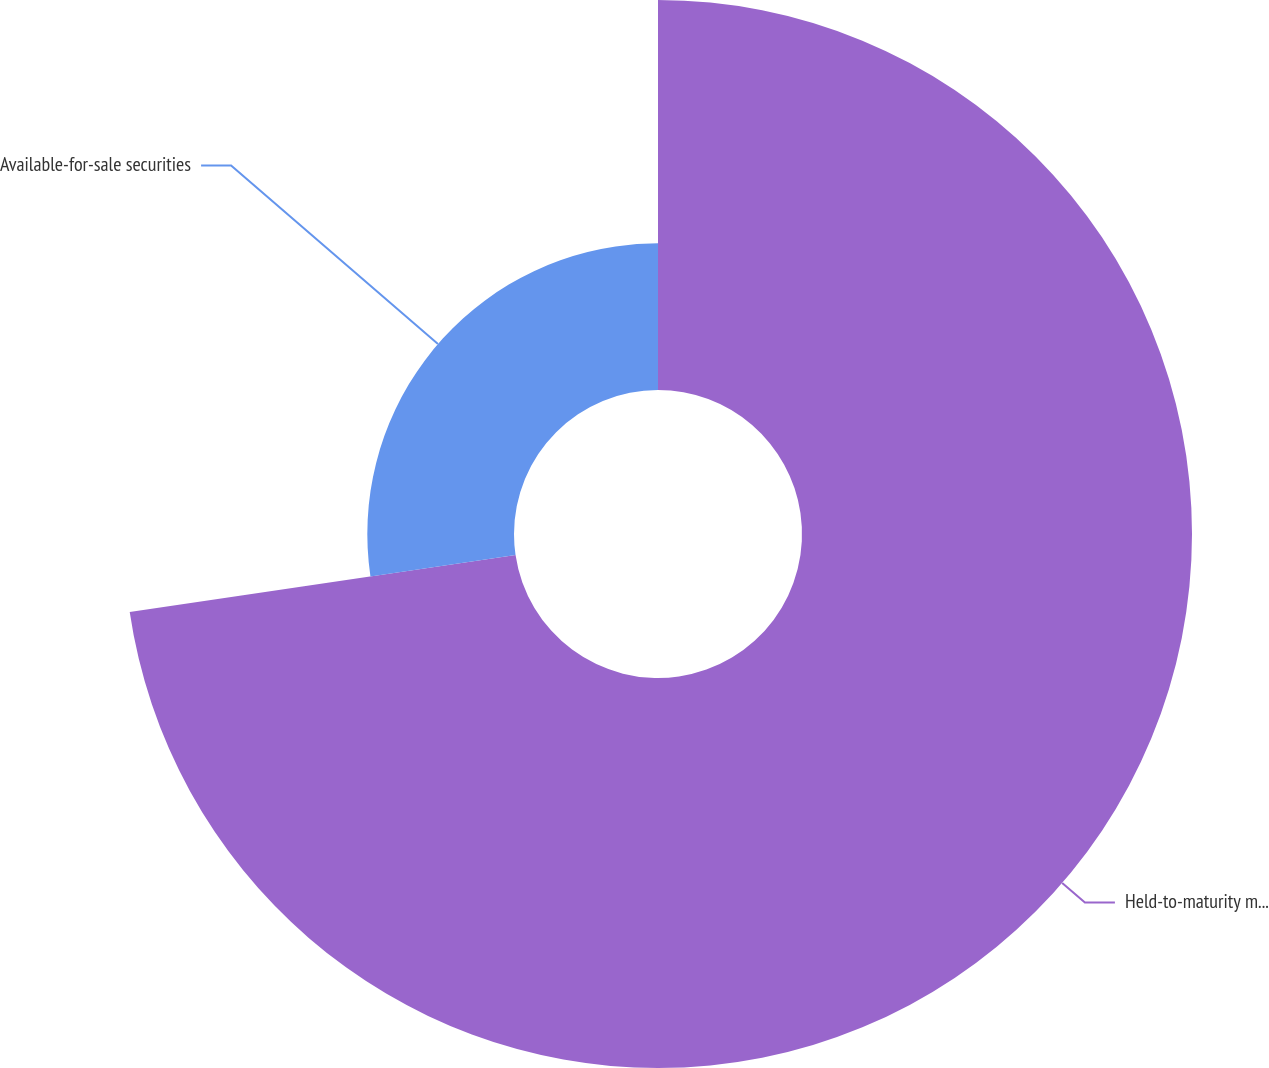<chart> <loc_0><loc_0><loc_500><loc_500><pie_chart><fcel>Held-to-maturity marketable<fcel>Available-for-sale securities<nl><fcel>72.67%<fcel>27.33%<nl></chart> 